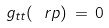<formula> <loc_0><loc_0><loc_500><loc_500>g _ { t t } ( \ r p ) \, = \, 0</formula> 